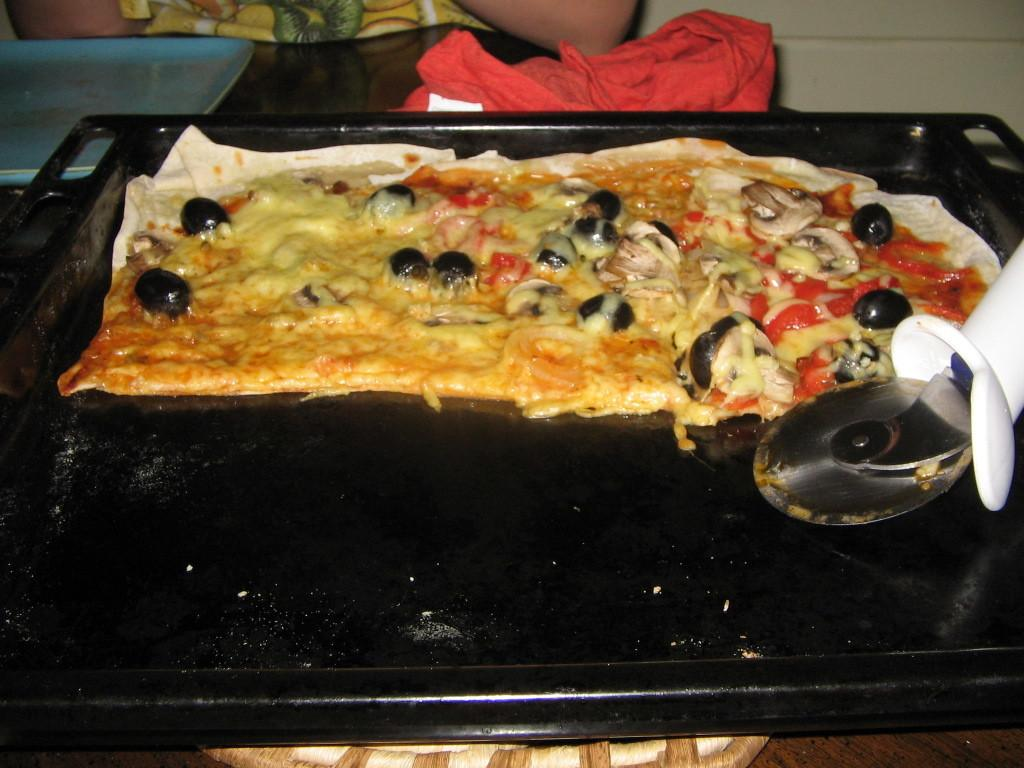What is placed in the tray that is visible in the image? There is food placed in a tray in the image. What tool is visible in the image? There is a cutter visible in the image. Can you describe the person in the background of the image? There is a person sitting in the background of the image. What color is the object placed on the table in the image? There is a red color object placed on the table in the image. What type of coast can be seen in the image? There is no coast visible in the image. What type of blade is being used by the person in the image? There is no blade being used by the person in the image; only a cutter is visible. 